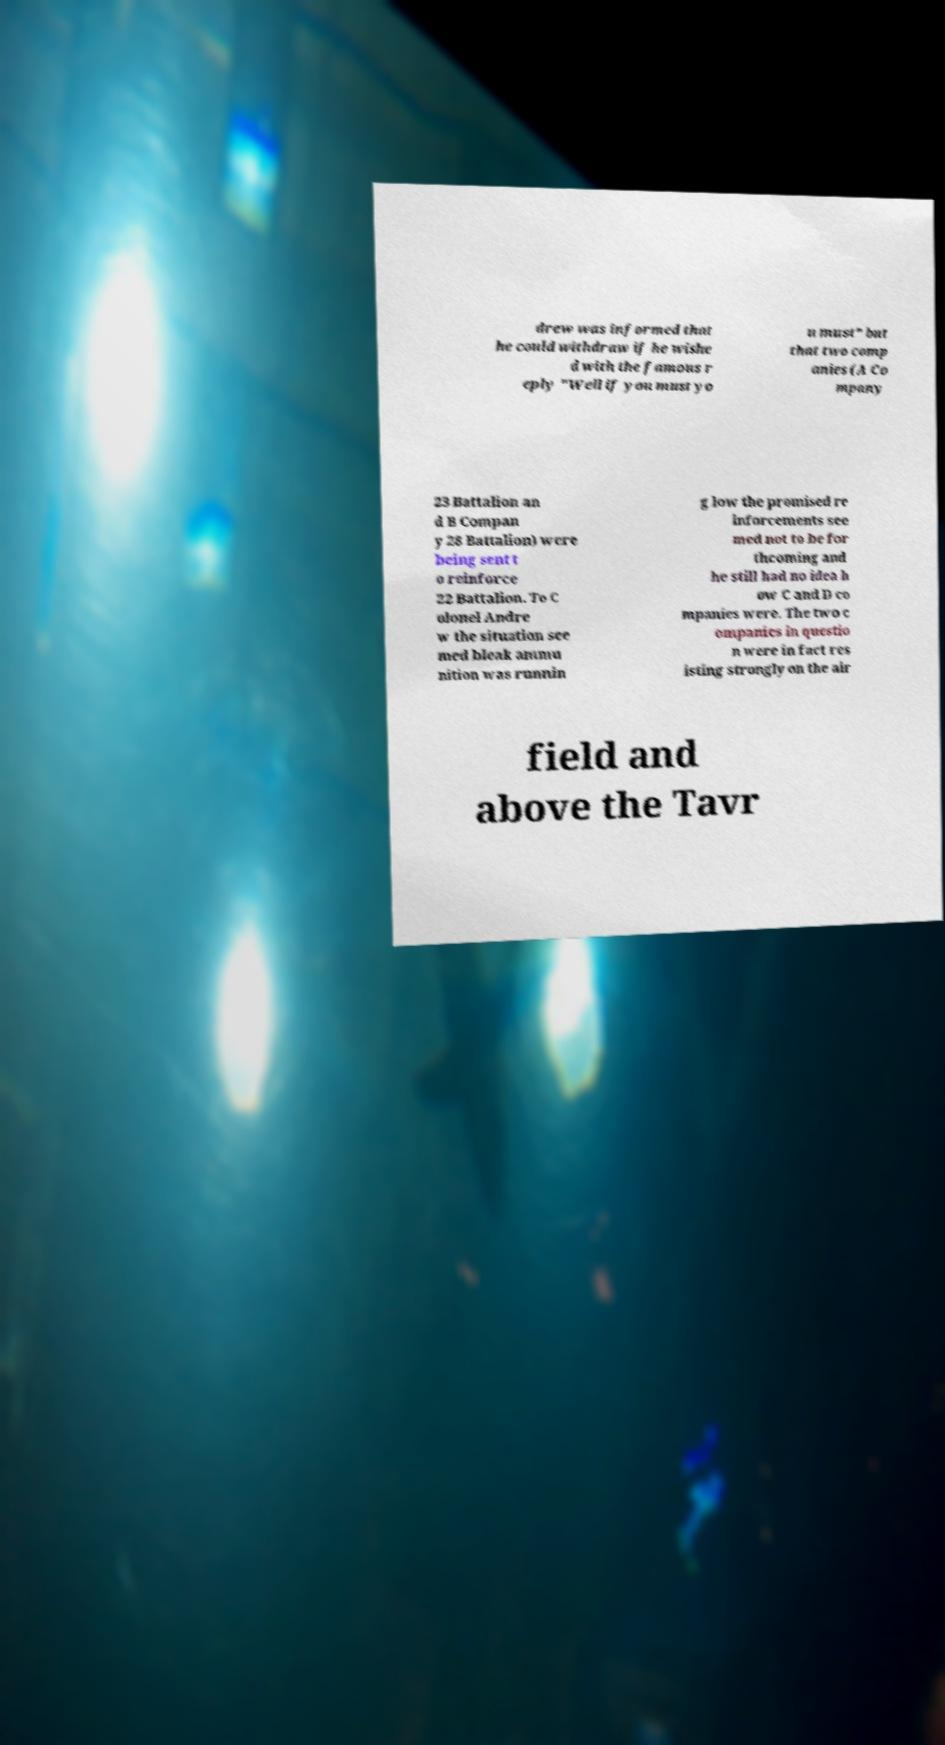Please read and relay the text visible in this image. What does it say? drew was informed that he could withdraw if he wishe d with the famous r eply "Well if you must yo u must" but that two comp anies (A Co mpany 23 Battalion an d B Compan y 28 Battalion) were being sent t o reinforce 22 Battalion. To C olonel Andre w the situation see med bleak ammu nition was runnin g low the promised re inforcements see med not to be for thcoming and he still had no idea h ow C and D co mpanies were. The two c ompanies in questio n were in fact res isting strongly on the air field and above the Tavr 